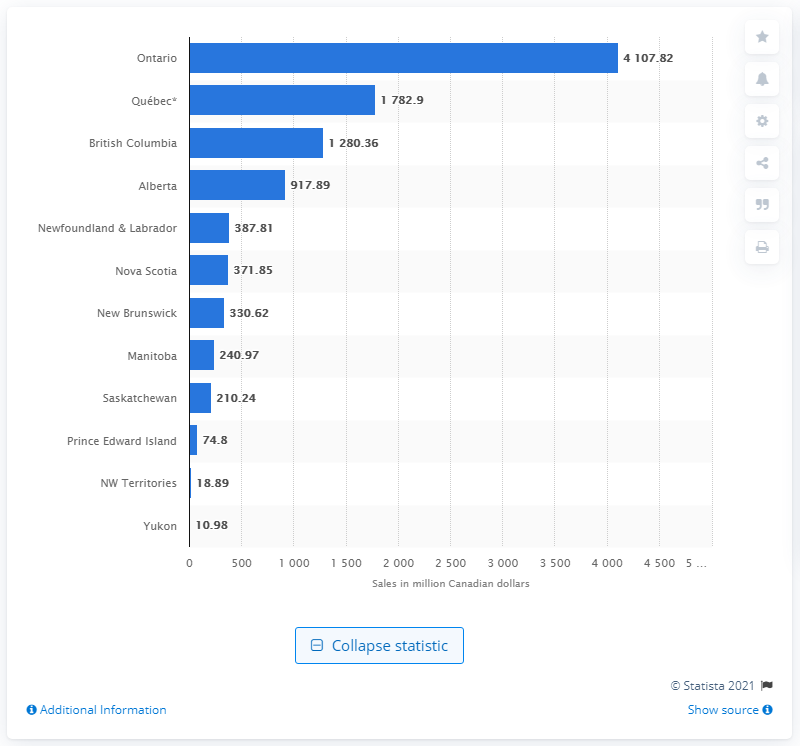Point out several critical features in this image. In 2020, the province of Ontario generated CAD 4,107.82 in lottery sales. In 2020, the Yukon generated CAD 10.98 million in lottery sales. 